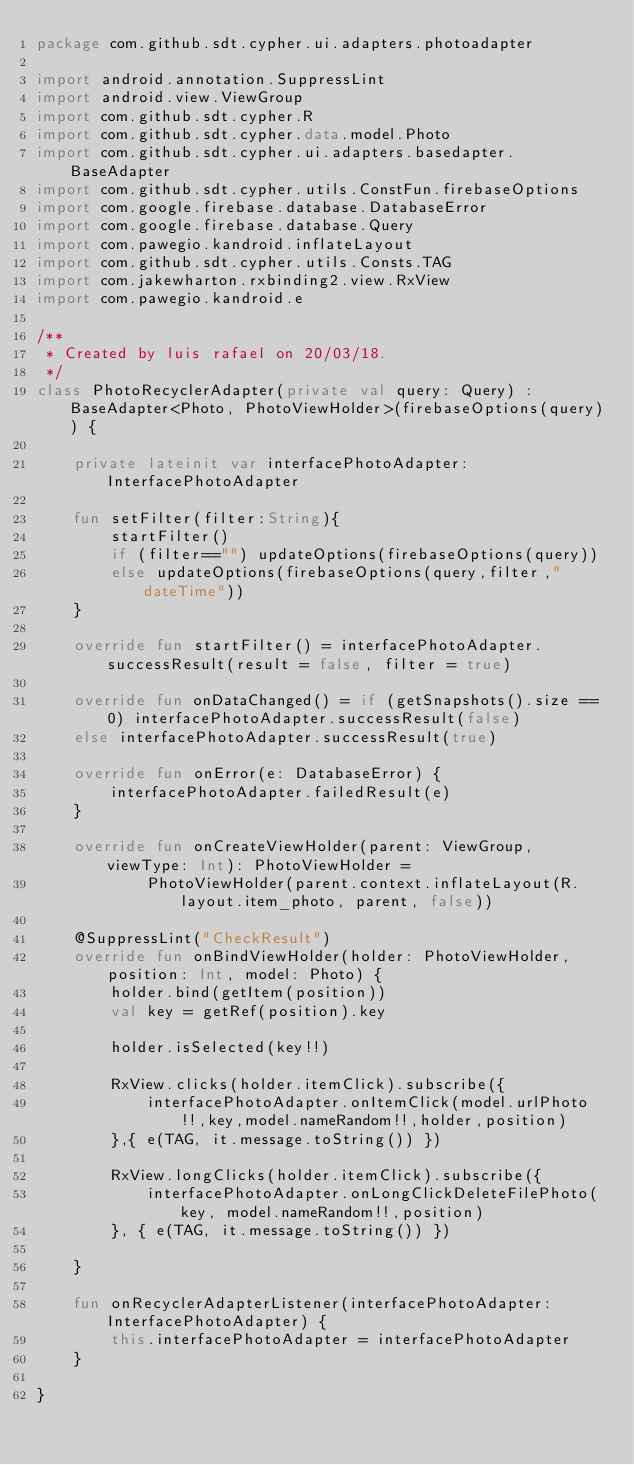<code> <loc_0><loc_0><loc_500><loc_500><_Kotlin_>package com.github.sdt.cypher.ui.adapters.photoadapter

import android.annotation.SuppressLint
import android.view.ViewGroup
import com.github.sdt.cypher.R
import com.github.sdt.cypher.data.model.Photo
import com.github.sdt.cypher.ui.adapters.basedapter.BaseAdapter
import com.github.sdt.cypher.utils.ConstFun.firebaseOptions
import com.google.firebase.database.DatabaseError
import com.google.firebase.database.Query
import com.pawegio.kandroid.inflateLayout
import com.github.sdt.cypher.utils.Consts.TAG
import com.jakewharton.rxbinding2.view.RxView
import com.pawegio.kandroid.e

/**
 * Created by luis rafael on 20/03/18.
 */
class PhotoRecyclerAdapter(private val query: Query) : BaseAdapter<Photo, PhotoViewHolder>(firebaseOptions(query)) {

    private lateinit var interfacePhotoAdapter: InterfacePhotoAdapter

    fun setFilter(filter:String){
        startFilter()
        if (filter=="") updateOptions(firebaseOptions(query))
        else updateOptions(firebaseOptions(query,filter,"dateTime"))
    }

    override fun startFilter() = interfacePhotoAdapter.successResult(result = false, filter = true)

    override fun onDataChanged() = if (getSnapshots().size == 0) interfacePhotoAdapter.successResult(false)
    else interfacePhotoAdapter.successResult(true)

    override fun onError(e: DatabaseError) {
        interfacePhotoAdapter.failedResult(e)
    }

    override fun onCreateViewHolder(parent: ViewGroup, viewType: Int): PhotoViewHolder =
            PhotoViewHolder(parent.context.inflateLayout(R.layout.item_photo, parent, false))

    @SuppressLint("CheckResult")
    override fun onBindViewHolder(holder: PhotoViewHolder, position: Int, model: Photo) {
        holder.bind(getItem(position))
        val key = getRef(position).key

        holder.isSelected(key!!)

        RxView.clicks(holder.itemClick).subscribe({
            interfacePhotoAdapter.onItemClick(model.urlPhoto!!,key,model.nameRandom!!,holder,position)
        },{ e(TAG, it.message.toString()) })

        RxView.longClicks(holder.itemClick).subscribe({
            interfacePhotoAdapter.onLongClickDeleteFilePhoto(key, model.nameRandom!!,position)
        }, { e(TAG, it.message.toString()) })

    }

    fun onRecyclerAdapterListener(interfacePhotoAdapter: InterfacePhotoAdapter) {
        this.interfacePhotoAdapter = interfacePhotoAdapter
    }

}</code> 